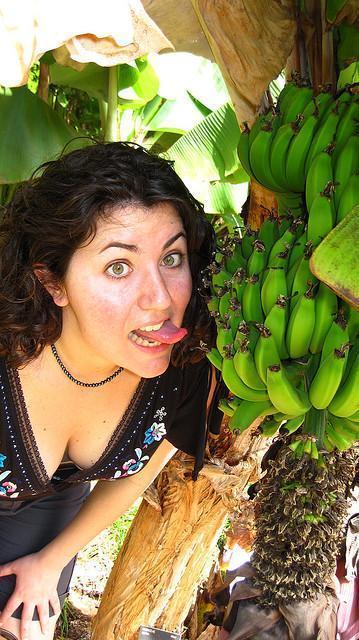How many sandwiches on each plate?
Give a very brief answer. 0. 